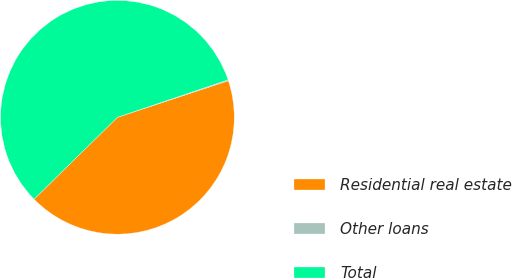Convert chart to OTSL. <chart><loc_0><loc_0><loc_500><loc_500><pie_chart><fcel>Residential real estate<fcel>Other loans<fcel>Total<nl><fcel>42.71%<fcel>0.13%<fcel>57.16%<nl></chart> 